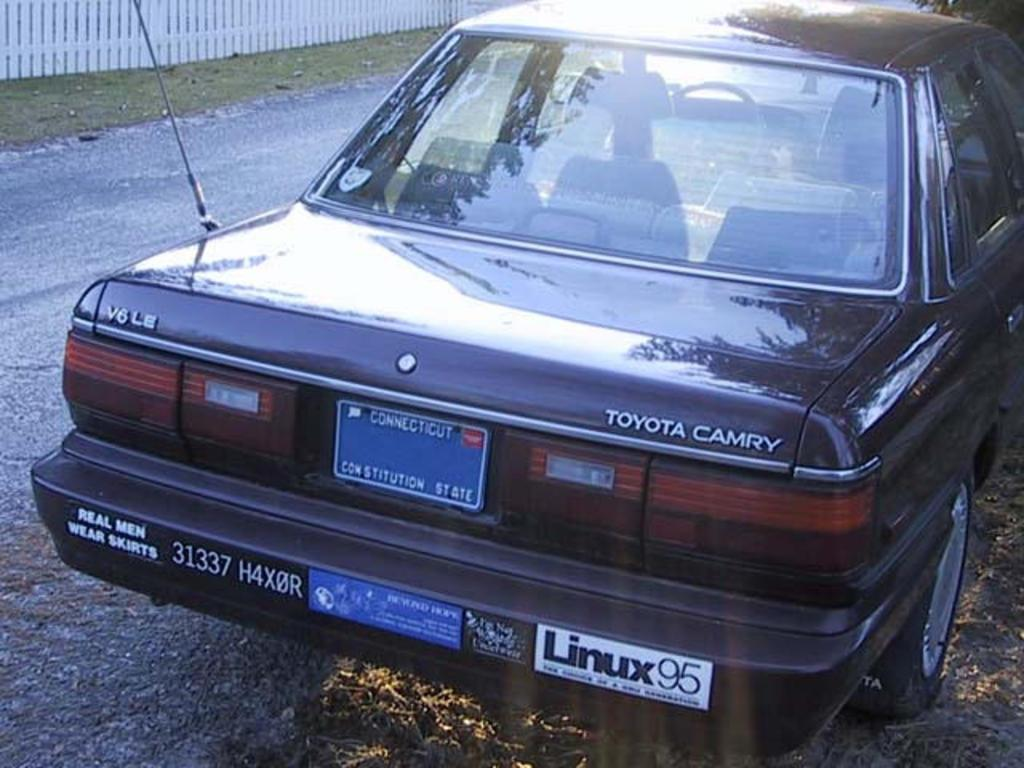What is the main subject of the image? There is a car in the image. Where is the car located? The car is on the side of the road. What can be seen in the background of the image? There is a white color railing in the background of the image. How many dimes are scattered on the ground near the car in the image? There are no dimes present in the image. What type of needle is being used to sew the car's tire in the image? There is no needle or sewing activity depicted in the image; it only shows a car on the side of the road. 